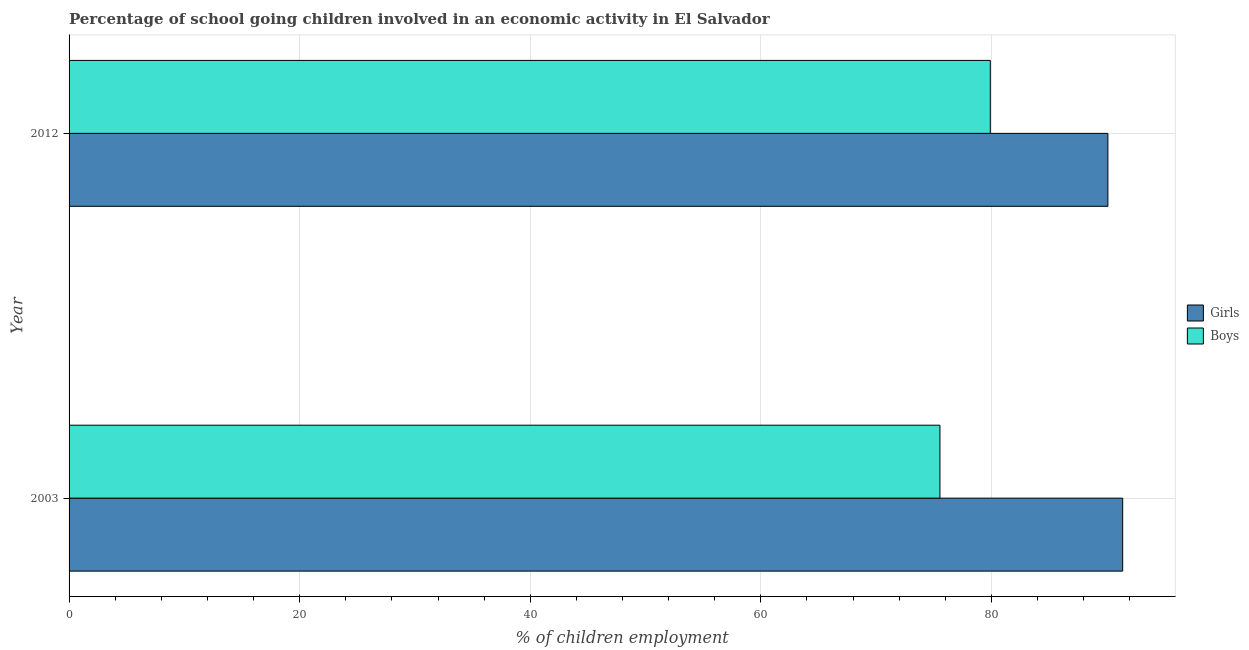How many different coloured bars are there?
Offer a very short reply. 2. How many bars are there on the 1st tick from the top?
Offer a very short reply. 2. How many bars are there on the 2nd tick from the bottom?
Keep it short and to the point. 2. What is the percentage of school going girls in 2012?
Offer a very short reply. 90.1. Across all years, what is the maximum percentage of school going boys?
Provide a succinct answer. 79.9. Across all years, what is the minimum percentage of school going girls?
Give a very brief answer. 90.1. What is the total percentage of school going boys in the graph?
Keep it short and to the point. 155.43. What is the difference between the percentage of school going girls in 2003 and that in 2012?
Provide a short and direct response. 1.28. What is the difference between the percentage of school going girls in 2003 and the percentage of school going boys in 2012?
Provide a succinct answer. 11.48. What is the average percentage of school going girls per year?
Make the answer very short. 90.74. In the year 2012, what is the difference between the percentage of school going girls and percentage of school going boys?
Make the answer very short. 10.2. What is the ratio of the percentage of school going girls in 2003 to that in 2012?
Offer a very short reply. 1.01. Is the difference between the percentage of school going boys in 2003 and 2012 greater than the difference between the percentage of school going girls in 2003 and 2012?
Give a very brief answer. No. In how many years, is the percentage of school going boys greater than the average percentage of school going boys taken over all years?
Ensure brevity in your answer.  1. What does the 2nd bar from the top in 2003 represents?
Your answer should be very brief. Girls. What does the 1st bar from the bottom in 2012 represents?
Provide a succinct answer. Girls. How many years are there in the graph?
Keep it short and to the point. 2. What is the difference between two consecutive major ticks on the X-axis?
Give a very brief answer. 20. Are the values on the major ticks of X-axis written in scientific E-notation?
Ensure brevity in your answer.  No. Does the graph contain any zero values?
Keep it short and to the point. No. Does the graph contain grids?
Provide a short and direct response. Yes. How many legend labels are there?
Your answer should be compact. 2. What is the title of the graph?
Keep it short and to the point. Percentage of school going children involved in an economic activity in El Salvador. What is the label or title of the X-axis?
Your answer should be compact. % of children employment. What is the label or title of the Y-axis?
Provide a succinct answer. Year. What is the % of children employment of Girls in 2003?
Your response must be concise. 91.38. What is the % of children employment of Boys in 2003?
Provide a succinct answer. 75.53. What is the % of children employment in Girls in 2012?
Keep it short and to the point. 90.1. What is the % of children employment of Boys in 2012?
Offer a very short reply. 79.9. Across all years, what is the maximum % of children employment of Girls?
Offer a terse response. 91.38. Across all years, what is the maximum % of children employment in Boys?
Offer a very short reply. 79.9. Across all years, what is the minimum % of children employment in Girls?
Your response must be concise. 90.1. Across all years, what is the minimum % of children employment in Boys?
Give a very brief answer. 75.53. What is the total % of children employment of Girls in the graph?
Your answer should be compact. 181.48. What is the total % of children employment of Boys in the graph?
Your response must be concise. 155.43. What is the difference between the % of children employment in Girls in 2003 and that in 2012?
Provide a succinct answer. 1.28. What is the difference between the % of children employment in Boys in 2003 and that in 2012?
Make the answer very short. -4.37. What is the difference between the % of children employment of Girls in 2003 and the % of children employment of Boys in 2012?
Provide a succinct answer. 11.48. What is the average % of children employment in Girls per year?
Your answer should be very brief. 90.74. What is the average % of children employment of Boys per year?
Your answer should be very brief. 77.72. In the year 2003, what is the difference between the % of children employment of Girls and % of children employment of Boys?
Offer a very short reply. 15.85. In the year 2012, what is the difference between the % of children employment in Girls and % of children employment in Boys?
Your response must be concise. 10.2. What is the ratio of the % of children employment of Girls in 2003 to that in 2012?
Offer a very short reply. 1.01. What is the ratio of the % of children employment in Boys in 2003 to that in 2012?
Offer a terse response. 0.95. What is the difference between the highest and the second highest % of children employment in Girls?
Your answer should be very brief. 1.28. What is the difference between the highest and the second highest % of children employment in Boys?
Your answer should be compact. 4.37. What is the difference between the highest and the lowest % of children employment of Girls?
Give a very brief answer. 1.28. What is the difference between the highest and the lowest % of children employment in Boys?
Your response must be concise. 4.37. 